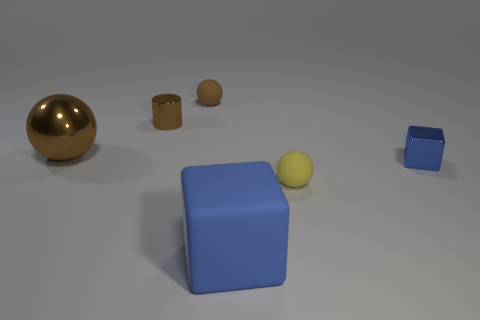Subtract all small matte balls. How many balls are left? 1 Subtract all red cubes. How many brown spheres are left? 2 Add 3 big spheres. How many objects exist? 9 Subtract all yellow balls. How many balls are left? 2 Subtract 2 balls. How many balls are left? 1 Subtract all cubes. How many objects are left? 4 Subtract all purple blocks. Subtract all purple balls. How many blocks are left? 2 Subtract all tiny rubber spheres. Subtract all blue metal cubes. How many objects are left? 3 Add 6 brown cylinders. How many brown cylinders are left? 7 Add 5 small yellow matte objects. How many small yellow matte objects exist? 6 